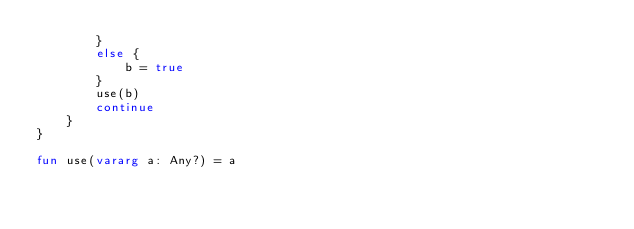Convert code to text. <code><loc_0><loc_0><loc_500><loc_500><_Kotlin_>        }
        else {
            b = true
        }
        use(b)
        continue
    }
}

fun use(vararg a: Any?) = a</code> 